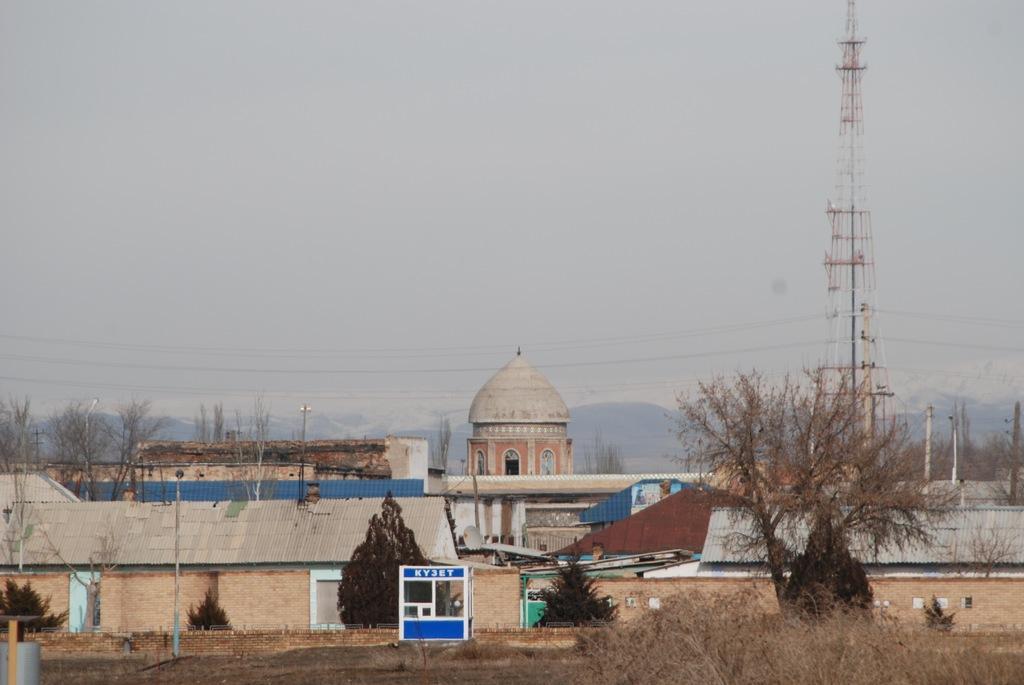Describe this image in one or two sentences. In this image there are plants and trees on the grassland. Right side there is a tower connected with wires. There are buildings and trees. Behind there are hills. Top of the image there is sky. 